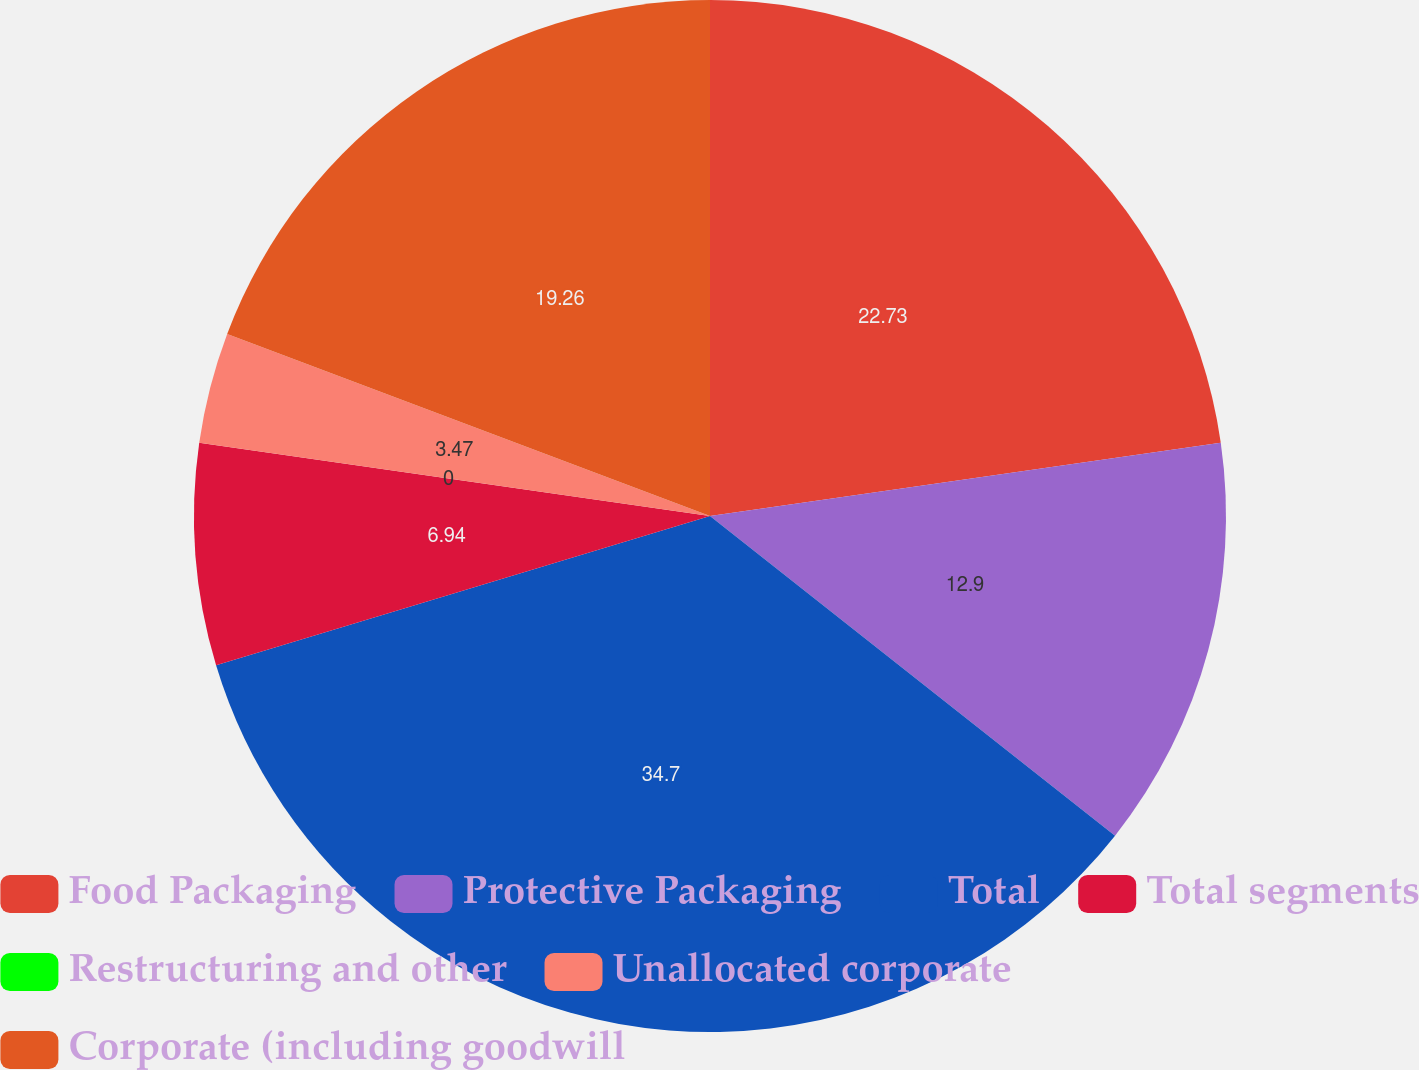Convert chart to OTSL. <chart><loc_0><loc_0><loc_500><loc_500><pie_chart><fcel>Food Packaging<fcel>Protective Packaging<fcel>Total<fcel>Total segments<fcel>Restructuring and other<fcel>Unallocated corporate<fcel>Corporate (including goodwill<nl><fcel>22.73%<fcel>12.9%<fcel>34.69%<fcel>6.94%<fcel>0.0%<fcel>3.47%<fcel>19.26%<nl></chart> 